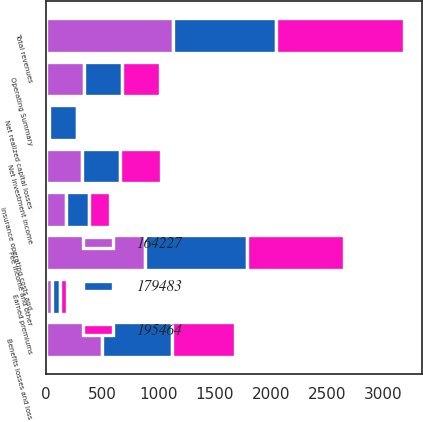Convert chart. <chart><loc_0><loc_0><loc_500><loc_500><stacked_bar_chart><ecel><fcel>Operating Summary<fcel>Fee income and other<fcel>Earned premiums<fcel>Net investment income<fcel>Net realized capital losses<fcel>Total revenues<fcel>Benefits losses and loss<fcel>Insurance operating costs and<nl><fcel>179483<fcel>338<fcel>899<fcel>71<fcel>338<fcel>252<fcel>914<fcel>627<fcel>202<nl><fcel>195464<fcel>338<fcel>870<fcel>62<fcel>359<fcel>28<fcel>1139<fcel>562<fcel>193<nl><fcel>164227<fcel>338<fcel>885<fcel>53<fcel>324<fcel>25<fcel>1131<fcel>497<fcel>179<nl></chart> 